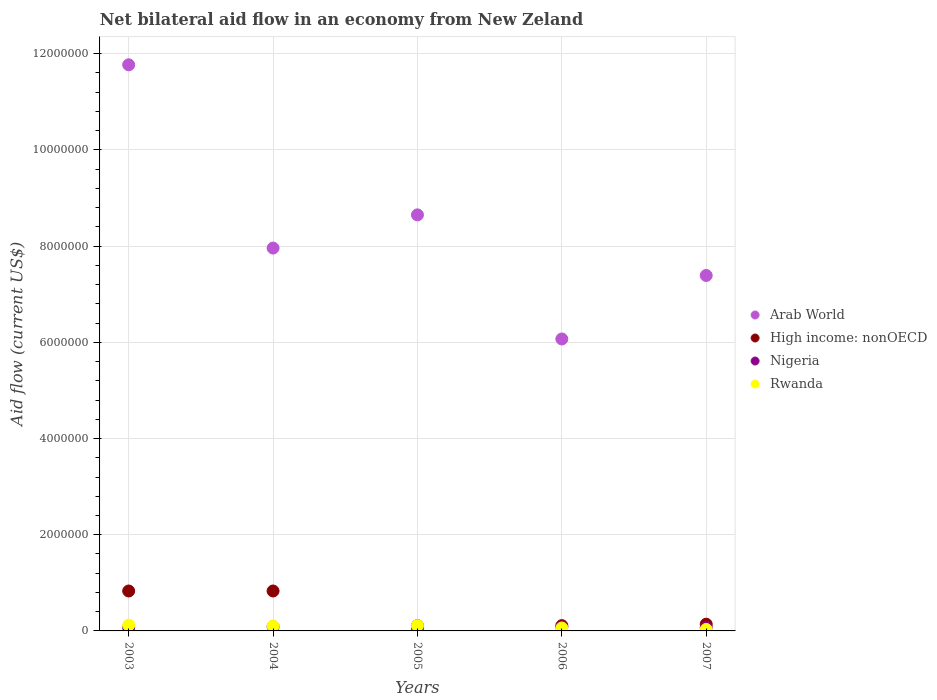What is the net bilateral aid flow in Arab World in 2006?
Ensure brevity in your answer.  6.07e+06. Across all years, what is the maximum net bilateral aid flow in Rwanda?
Offer a terse response. 1.20e+05. What is the total net bilateral aid flow in Nigeria in the graph?
Your answer should be very brief. 3.70e+05. What is the difference between the net bilateral aid flow in Nigeria in 2003 and that in 2007?
Provide a short and direct response. 0. What is the difference between the net bilateral aid flow in Arab World in 2006 and the net bilateral aid flow in High income: nonOECD in 2005?
Your answer should be compact. 5.96e+06. What is the average net bilateral aid flow in Arab World per year?
Offer a terse response. 8.37e+06. In the year 2006, what is the difference between the net bilateral aid flow in High income: nonOECD and net bilateral aid flow in Nigeria?
Make the answer very short. 3.00e+04. What is the ratio of the net bilateral aid flow in Arab World in 2006 to that in 2007?
Your response must be concise. 0.82. Is the net bilateral aid flow in High income: nonOECD in 2004 less than that in 2006?
Ensure brevity in your answer.  No. Is the difference between the net bilateral aid flow in High income: nonOECD in 2005 and 2007 greater than the difference between the net bilateral aid flow in Nigeria in 2005 and 2007?
Keep it short and to the point. No. What is the difference between the highest and the second highest net bilateral aid flow in Arab World?
Provide a succinct answer. 3.12e+06. What is the difference between the highest and the lowest net bilateral aid flow in High income: nonOECD?
Your answer should be compact. 7.20e+05. In how many years, is the net bilateral aid flow in Rwanda greater than the average net bilateral aid flow in Rwanda taken over all years?
Provide a short and direct response. 3. Is the sum of the net bilateral aid flow in Arab World in 2006 and 2007 greater than the maximum net bilateral aid flow in High income: nonOECD across all years?
Ensure brevity in your answer.  Yes. Does the net bilateral aid flow in High income: nonOECD monotonically increase over the years?
Provide a short and direct response. No. How many dotlines are there?
Offer a very short reply. 4. How many years are there in the graph?
Your answer should be very brief. 5. Are the values on the major ticks of Y-axis written in scientific E-notation?
Give a very brief answer. No. Does the graph contain any zero values?
Provide a short and direct response. No. Does the graph contain grids?
Ensure brevity in your answer.  Yes. Where does the legend appear in the graph?
Keep it short and to the point. Center right. How many legend labels are there?
Give a very brief answer. 4. What is the title of the graph?
Keep it short and to the point. Net bilateral aid flow in an economy from New Zeland. What is the label or title of the X-axis?
Your answer should be compact. Years. What is the label or title of the Y-axis?
Your response must be concise. Aid flow (current US$). What is the Aid flow (current US$) in Arab World in 2003?
Provide a short and direct response. 1.18e+07. What is the Aid flow (current US$) in High income: nonOECD in 2003?
Offer a very short reply. 8.30e+05. What is the Aid flow (current US$) of Rwanda in 2003?
Offer a very short reply. 1.20e+05. What is the Aid flow (current US$) in Arab World in 2004?
Provide a succinct answer. 7.96e+06. What is the Aid flow (current US$) of High income: nonOECD in 2004?
Your answer should be very brief. 8.30e+05. What is the Aid flow (current US$) of Rwanda in 2004?
Your answer should be very brief. 1.00e+05. What is the Aid flow (current US$) in Arab World in 2005?
Make the answer very short. 8.65e+06. What is the Aid flow (current US$) in High income: nonOECD in 2005?
Offer a very short reply. 1.10e+05. What is the Aid flow (current US$) of Arab World in 2006?
Give a very brief answer. 6.07e+06. What is the Aid flow (current US$) of Rwanda in 2006?
Keep it short and to the point. 6.00e+04. What is the Aid flow (current US$) in Arab World in 2007?
Provide a short and direct response. 7.39e+06. Across all years, what is the maximum Aid flow (current US$) in Arab World?
Offer a very short reply. 1.18e+07. Across all years, what is the maximum Aid flow (current US$) in High income: nonOECD?
Your answer should be compact. 8.30e+05. Across all years, what is the minimum Aid flow (current US$) in Arab World?
Offer a very short reply. 6.07e+06. Across all years, what is the minimum Aid flow (current US$) in High income: nonOECD?
Your answer should be very brief. 1.10e+05. Across all years, what is the minimum Aid flow (current US$) in Rwanda?
Your answer should be compact. 3.00e+04. What is the total Aid flow (current US$) of Arab World in the graph?
Your answer should be very brief. 4.18e+07. What is the total Aid flow (current US$) in High income: nonOECD in the graph?
Make the answer very short. 2.02e+06. What is the difference between the Aid flow (current US$) in Arab World in 2003 and that in 2004?
Provide a succinct answer. 3.81e+06. What is the difference between the Aid flow (current US$) of High income: nonOECD in 2003 and that in 2004?
Your response must be concise. 0. What is the difference between the Aid flow (current US$) of Arab World in 2003 and that in 2005?
Provide a short and direct response. 3.12e+06. What is the difference between the Aid flow (current US$) in High income: nonOECD in 2003 and that in 2005?
Provide a succinct answer. 7.20e+05. What is the difference between the Aid flow (current US$) in Nigeria in 2003 and that in 2005?
Provide a succinct answer. 10000. What is the difference between the Aid flow (current US$) of Arab World in 2003 and that in 2006?
Offer a very short reply. 5.70e+06. What is the difference between the Aid flow (current US$) of High income: nonOECD in 2003 and that in 2006?
Make the answer very short. 7.20e+05. What is the difference between the Aid flow (current US$) of Nigeria in 2003 and that in 2006?
Provide a short and direct response. -10000. What is the difference between the Aid flow (current US$) in Arab World in 2003 and that in 2007?
Offer a very short reply. 4.38e+06. What is the difference between the Aid flow (current US$) in High income: nonOECD in 2003 and that in 2007?
Offer a very short reply. 6.90e+05. What is the difference between the Aid flow (current US$) of Nigeria in 2003 and that in 2007?
Offer a terse response. 0. What is the difference between the Aid flow (current US$) in Rwanda in 2003 and that in 2007?
Give a very brief answer. 9.00e+04. What is the difference between the Aid flow (current US$) in Arab World in 2004 and that in 2005?
Provide a succinct answer. -6.90e+05. What is the difference between the Aid flow (current US$) of High income: nonOECD in 2004 and that in 2005?
Provide a short and direct response. 7.20e+05. What is the difference between the Aid flow (current US$) of Arab World in 2004 and that in 2006?
Give a very brief answer. 1.89e+06. What is the difference between the Aid flow (current US$) of High income: nonOECD in 2004 and that in 2006?
Offer a very short reply. 7.20e+05. What is the difference between the Aid flow (current US$) in Nigeria in 2004 and that in 2006?
Offer a terse response. 10000. What is the difference between the Aid flow (current US$) of Arab World in 2004 and that in 2007?
Provide a short and direct response. 5.70e+05. What is the difference between the Aid flow (current US$) of High income: nonOECD in 2004 and that in 2007?
Keep it short and to the point. 6.90e+05. What is the difference between the Aid flow (current US$) in Nigeria in 2004 and that in 2007?
Ensure brevity in your answer.  2.00e+04. What is the difference between the Aid flow (current US$) of Arab World in 2005 and that in 2006?
Your answer should be compact. 2.58e+06. What is the difference between the Aid flow (current US$) of High income: nonOECD in 2005 and that in 2006?
Your response must be concise. 0. What is the difference between the Aid flow (current US$) in Arab World in 2005 and that in 2007?
Your answer should be very brief. 1.26e+06. What is the difference between the Aid flow (current US$) of High income: nonOECD in 2005 and that in 2007?
Your answer should be very brief. -3.00e+04. What is the difference between the Aid flow (current US$) in Nigeria in 2005 and that in 2007?
Provide a succinct answer. -10000. What is the difference between the Aid flow (current US$) of Arab World in 2006 and that in 2007?
Keep it short and to the point. -1.32e+06. What is the difference between the Aid flow (current US$) of Nigeria in 2006 and that in 2007?
Make the answer very short. 10000. What is the difference between the Aid flow (current US$) of Arab World in 2003 and the Aid flow (current US$) of High income: nonOECD in 2004?
Offer a terse response. 1.09e+07. What is the difference between the Aid flow (current US$) in Arab World in 2003 and the Aid flow (current US$) in Nigeria in 2004?
Give a very brief answer. 1.17e+07. What is the difference between the Aid flow (current US$) of Arab World in 2003 and the Aid flow (current US$) of Rwanda in 2004?
Offer a very short reply. 1.17e+07. What is the difference between the Aid flow (current US$) in High income: nonOECD in 2003 and the Aid flow (current US$) in Nigeria in 2004?
Ensure brevity in your answer.  7.40e+05. What is the difference between the Aid flow (current US$) in High income: nonOECD in 2003 and the Aid flow (current US$) in Rwanda in 2004?
Your response must be concise. 7.30e+05. What is the difference between the Aid flow (current US$) of Nigeria in 2003 and the Aid flow (current US$) of Rwanda in 2004?
Keep it short and to the point. -3.00e+04. What is the difference between the Aid flow (current US$) in Arab World in 2003 and the Aid flow (current US$) in High income: nonOECD in 2005?
Make the answer very short. 1.17e+07. What is the difference between the Aid flow (current US$) in Arab World in 2003 and the Aid flow (current US$) in Nigeria in 2005?
Ensure brevity in your answer.  1.17e+07. What is the difference between the Aid flow (current US$) in Arab World in 2003 and the Aid flow (current US$) in Rwanda in 2005?
Ensure brevity in your answer.  1.17e+07. What is the difference between the Aid flow (current US$) of High income: nonOECD in 2003 and the Aid flow (current US$) of Nigeria in 2005?
Keep it short and to the point. 7.70e+05. What is the difference between the Aid flow (current US$) of High income: nonOECD in 2003 and the Aid flow (current US$) of Rwanda in 2005?
Offer a terse response. 7.20e+05. What is the difference between the Aid flow (current US$) of Nigeria in 2003 and the Aid flow (current US$) of Rwanda in 2005?
Offer a very short reply. -4.00e+04. What is the difference between the Aid flow (current US$) in Arab World in 2003 and the Aid flow (current US$) in High income: nonOECD in 2006?
Provide a short and direct response. 1.17e+07. What is the difference between the Aid flow (current US$) of Arab World in 2003 and the Aid flow (current US$) of Nigeria in 2006?
Give a very brief answer. 1.17e+07. What is the difference between the Aid flow (current US$) of Arab World in 2003 and the Aid flow (current US$) of Rwanda in 2006?
Your answer should be compact. 1.17e+07. What is the difference between the Aid flow (current US$) in High income: nonOECD in 2003 and the Aid flow (current US$) in Nigeria in 2006?
Offer a very short reply. 7.50e+05. What is the difference between the Aid flow (current US$) of High income: nonOECD in 2003 and the Aid flow (current US$) of Rwanda in 2006?
Give a very brief answer. 7.70e+05. What is the difference between the Aid flow (current US$) of Nigeria in 2003 and the Aid flow (current US$) of Rwanda in 2006?
Offer a terse response. 10000. What is the difference between the Aid flow (current US$) in Arab World in 2003 and the Aid flow (current US$) in High income: nonOECD in 2007?
Your response must be concise. 1.16e+07. What is the difference between the Aid flow (current US$) in Arab World in 2003 and the Aid flow (current US$) in Nigeria in 2007?
Ensure brevity in your answer.  1.17e+07. What is the difference between the Aid flow (current US$) in Arab World in 2003 and the Aid flow (current US$) in Rwanda in 2007?
Offer a terse response. 1.17e+07. What is the difference between the Aid flow (current US$) of High income: nonOECD in 2003 and the Aid flow (current US$) of Nigeria in 2007?
Your response must be concise. 7.60e+05. What is the difference between the Aid flow (current US$) in High income: nonOECD in 2003 and the Aid flow (current US$) in Rwanda in 2007?
Make the answer very short. 8.00e+05. What is the difference between the Aid flow (current US$) in Nigeria in 2003 and the Aid flow (current US$) in Rwanda in 2007?
Offer a very short reply. 4.00e+04. What is the difference between the Aid flow (current US$) in Arab World in 2004 and the Aid flow (current US$) in High income: nonOECD in 2005?
Provide a short and direct response. 7.85e+06. What is the difference between the Aid flow (current US$) of Arab World in 2004 and the Aid flow (current US$) of Nigeria in 2005?
Make the answer very short. 7.90e+06. What is the difference between the Aid flow (current US$) in Arab World in 2004 and the Aid flow (current US$) in Rwanda in 2005?
Ensure brevity in your answer.  7.85e+06. What is the difference between the Aid flow (current US$) in High income: nonOECD in 2004 and the Aid flow (current US$) in Nigeria in 2005?
Give a very brief answer. 7.70e+05. What is the difference between the Aid flow (current US$) in High income: nonOECD in 2004 and the Aid flow (current US$) in Rwanda in 2005?
Offer a very short reply. 7.20e+05. What is the difference between the Aid flow (current US$) of Nigeria in 2004 and the Aid flow (current US$) of Rwanda in 2005?
Your answer should be compact. -2.00e+04. What is the difference between the Aid flow (current US$) of Arab World in 2004 and the Aid flow (current US$) of High income: nonOECD in 2006?
Give a very brief answer. 7.85e+06. What is the difference between the Aid flow (current US$) of Arab World in 2004 and the Aid flow (current US$) of Nigeria in 2006?
Provide a succinct answer. 7.88e+06. What is the difference between the Aid flow (current US$) of Arab World in 2004 and the Aid flow (current US$) of Rwanda in 2006?
Provide a short and direct response. 7.90e+06. What is the difference between the Aid flow (current US$) of High income: nonOECD in 2004 and the Aid flow (current US$) of Nigeria in 2006?
Offer a very short reply. 7.50e+05. What is the difference between the Aid flow (current US$) in High income: nonOECD in 2004 and the Aid flow (current US$) in Rwanda in 2006?
Ensure brevity in your answer.  7.70e+05. What is the difference between the Aid flow (current US$) in Nigeria in 2004 and the Aid flow (current US$) in Rwanda in 2006?
Provide a succinct answer. 3.00e+04. What is the difference between the Aid flow (current US$) of Arab World in 2004 and the Aid flow (current US$) of High income: nonOECD in 2007?
Provide a short and direct response. 7.82e+06. What is the difference between the Aid flow (current US$) in Arab World in 2004 and the Aid flow (current US$) in Nigeria in 2007?
Your answer should be compact. 7.89e+06. What is the difference between the Aid flow (current US$) in Arab World in 2004 and the Aid flow (current US$) in Rwanda in 2007?
Your answer should be very brief. 7.93e+06. What is the difference between the Aid flow (current US$) in High income: nonOECD in 2004 and the Aid flow (current US$) in Nigeria in 2007?
Make the answer very short. 7.60e+05. What is the difference between the Aid flow (current US$) in High income: nonOECD in 2004 and the Aid flow (current US$) in Rwanda in 2007?
Keep it short and to the point. 8.00e+05. What is the difference between the Aid flow (current US$) of Arab World in 2005 and the Aid flow (current US$) of High income: nonOECD in 2006?
Provide a short and direct response. 8.54e+06. What is the difference between the Aid flow (current US$) in Arab World in 2005 and the Aid flow (current US$) in Nigeria in 2006?
Your answer should be compact. 8.57e+06. What is the difference between the Aid flow (current US$) of Arab World in 2005 and the Aid flow (current US$) of Rwanda in 2006?
Provide a short and direct response. 8.59e+06. What is the difference between the Aid flow (current US$) in High income: nonOECD in 2005 and the Aid flow (current US$) in Nigeria in 2006?
Keep it short and to the point. 3.00e+04. What is the difference between the Aid flow (current US$) in Nigeria in 2005 and the Aid flow (current US$) in Rwanda in 2006?
Give a very brief answer. 0. What is the difference between the Aid flow (current US$) in Arab World in 2005 and the Aid flow (current US$) in High income: nonOECD in 2007?
Make the answer very short. 8.51e+06. What is the difference between the Aid flow (current US$) of Arab World in 2005 and the Aid flow (current US$) of Nigeria in 2007?
Provide a succinct answer. 8.58e+06. What is the difference between the Aid flow (current US$) in Arab World in 2005 and the Aid flow (current US$) in Rwanda in 2007?
Your answer should be very brief. 8.62e+06. What is the difference between the Aid flow (current US$) in Nigeria in 2005 and the Aid flow (current US$) in Rwanda in 2007?
Offer a terse response. 3.00e+04. What is the difference between the Aid flow (current US$) in Arab World in 2006 and the Aid flow (current US$) in High income: nonOECD in 2007?
Provide a short and direct response. 5.93e+06. What is the difference between the Aid flow (current US$) in Arab World in 2006 and the Aid flow (current US$) in Rwanda in 2007?
Ensure brevity in your answer.  6.04e+06. What is the difference between the Aid flow (current US$) of Nigeria in 2006 and the Aid flow (current US$) of Rwanda in 2007?
Offer a terse response. 5.00e+04. What is the average Aid flow (current US$) in Arab World per year?
Provide a short and direct response. 8.37e+06. What is the average Aid flow (current US$) of High income: nonOECD per year?
Offer a terse response. 4.04e+05. What is the average Aid flow (current US$) in Nigeria per year?
Offer a terse response. 7.40e+04. What is the average Aid flow (current US$) in Rwanda per year?
Your response must be concise. 8.40e+04. In the year 2003, what is the difference between the Aid flow (current US$) of Arab World and Aid flow (current US$) of High income: nonOECD?
Offer a very short reply. 1.09e+07. In the year 2003, what is the difference between the Aid flow (current US$) of Arab World and Aid flow (current US$) of Nigeria?
Your answer should be very brief. 1.17e+07. In the year 2003, what is the difference between the Aid flow (current US$) of Arab World and Aid flow (current US$) of Rwanda?
Provide a short and direct response. 1.16e+07. In the year 2003, what is the difference between the Aid flow (current US$) of High income: nonOECD and Aid flow (current US$) of Nigeria?
Provide a succinct answer. 7.60e+05. In the year 2003, what is the difference between the Aid flow (current US$) in High income: nonOECD and Aid flow (current US$) in Rwanda?
Offer a terse response. 7.10e+05. In the year 2003, what is the difference between the Aid flow (current US$) of Nigeria and Aid flow (current US$) of Rwanda?
Your response must be concise. -5.00e+04. In the year 2004, what is the difference between the Aid flow (current US$) of Arab World and Aid flow (current US$) of High income: nonOECD?
Provide a succinct answer. 7.13e+06. In the year 2004, what is the difference between the Aid flow (current US$) in Arab World and Aid flow (current US$) in Nigeria?
Provide a succinct answer. 7.87e+06. In the year 2004, what is the difference between the Aid flow (current US$) of Arab World and Aid flow (current US$) of Rwanda?
Make the answer very short. 7.86e+06. In the year 2004, what is the difference between the Aid flow (current US$) in High income: nonOECD and Aid flow (current US$) in Nigeria?
Provide a succinct answer. 7.40e+05. In the year 2004, what is the difference between the Aid flow (current US$) in High income: nonOECD and Aid flow (current US$) in Rwanda?
Your response must be concise. 7.30e+05. In the year 2005, what is the difference between the Aid flow (current US$) in Arab World and Aid flow (current US$) in High income: nonOECD?
Ensure brevity in your answer.  8.54e+06. In the year 2005, what is the difference between the Aid flow (current US$) in Arab World and Aid flow (current US$) in Nigeria?
Offer a terse response. 8.59e+06. In the year 2005, what is the difference between the Aid flow (current US$) of Arab World and Aid flow (current US$) of Rwanda?
Offer a terse response. 8.54e+06. In the year 2005, what is the difference between the Aid flow (current US$) in High income: nonOECD and Aid flow (current US$) in Nigeria?
Your answer should be very brief. 5.00e+04. In the year 2006, what is the difference between the Aid flow (current US$) in Arab World and Aid flow (current US$) in High income: nonOECD?
Offer a very short reply. 5.96e+06. In the year 2006, what is the difference between the Aid flow (current US$) in Arab World and Aid flow (current US$) in Nigeria?
Ensure brevity in your answer.  5.99e+06. In the year 2006, what is the difference between the Aid flow (current US$) of Arab World and Aid flow (current US$) of Rwanda?
Your answer should be very brief. 6.01e+06. In the year 2006, what is the difference between the Aid flow (current US$) in High income: nonOECD and Aid flow (current US$) in Nigeria?
Keep it short and to the point. 3.00e+04. In the year 2006, what is the difference between the Aid flow (current US$) in Nigeria and Aid flow (current US$) in Rwanda?
Your response must be concise. 2.00e+04. In the year 2007, what is the difference between the Aid flow (current US$) in Arab World and Aid flow (current US$) in High income: nonOECD?
Your answer should be compact. 7.25e+06. In the year 2007, what is the difference between the Aid flow (current US$) in Arab World and Aid flow (current US$) in Nigeria?
Your answer should be very brief. 7.32e+06. In the year 2007, what is the difference between the Aid flow (current US$) of Arab World and Aid flow (current US$) of Rwanda?
Offer a terse response. 7.36e+06. In the year 2007, what is the difference between the Aid flow (current US$) of High income: nonOECD and Aid flow (current US$) of Rwanda?
Keep it short and to the point. 1.10e+05. What is the ratio of the Aid flow (current US$) of Arab World in 2003 to that in 2004?
Keep it short and to the point. 1.48. What is the ratio of the Aid flow (current US$) of Rwanda in 2003 to that in 2004?
Provide a succinct answer. 1.2. What is the ratio of the Aid flow (current US$) in Arab World in 2003 to that in 2005?
Keep it short and to the point. 1.36. What is the ratio of the Aid flow (current US$) of High income: nonOECD in 2003 to that in 2005?
Offer a terse response. 7.55. What is the ratio of the Aid flow (current US$) of Arab World in 2003 to that in 2006?
Your answer should be very brief. 1.94. What is the ratio of the Aid flow (current US$) of High income: nonOECD in 2003 to that in 2006?
Offer a terse response. 7.55. What is the ratio of the Aid flow (current US$) in Nigeria in 2003 to that in 2006?
Provide a succinct answer. 0.88. What is the ratio of the Aid flow (current US$) of Arab World in 2003 to that in 2007?
Your answer should be very brief. 1.59. What is the ratio of the Aid flow (current US$) in High income: nonOECD in 2003 to that in 2007?
Make the answer very short. 5.93. What is the ratio of the Aid flow (current US$) in Arab World in 2004 to that in 2005?
Give a very brief answer. 0.92. What is the ratio of the Aid flow (current US$) of High income: nonOECD in 2004 to that in 2005?
Make the answer very short. 7.55. What is the ratio of the Aid flow (current US$) in Rwanda in 2004 to that in 2005?
Your answer should be compact. 0.91. What is the ratio of the Aid flow (current US$) of Arab World in 2004 to that in 2006?
Your answer should be very brief. 1.31. What is the ratio of the Aid flow (current US$) in High income: nonOECD in 2004 to that in 2006?
Your answer should be compact. 7.55. What is the ratio of the Aid flow (current US$) in Rwanda in 2004 to that in 2006?
Give a very brief answer. 1.67. What is the ratio of the Aid flow (current US$) of Arab World in 2004 to that in 2007?
Your answer should be very brief. 1.08. What is the ratio of the Aid flow (current US$) of High income: nonOECD in 2004 to that in 2007?
Make the answer very short. 5.93. What is the ratio of the Aid flow (current US$) in Nigeria in 2004 to that in 2007?
Your answer should be very brief. 1.29. What is the ratio of the Aid flow (current US$) of Arab World in 2005 to that in 2006?
Offer a very short reply. 1.43. What is the ratio of the Aid flow (current US$) of High income: nonOECD in 2005 to that in 2006?
Keep it short and to the point. 1. What is the ratio of the Aid flow (current US$) in Rwanda in 2005 to that in 2006?
Keep it short and to the point. 1.83. What is the ratio of the Aid flow (current US$) of Arab World in 2005 to that in 2007?
Ensure brevity in your answer.  1.17. What is the ratio of the Aid flow (current US$) in High income: nonOECD in 2005 to that in 2007?
Your answer should be very brief. 0.79. What is the ratio of the Aid flow (current US$) in Nigeria in 2005 to that in 2007?
Your answer should be compact. 0.86. What is the ratio of the Aid flow (current US$) in Rwanda in 2005 to that in 2007?
Provide a succinct answer. 3.67. What is the ratio of the Aid flow (current US$) of Arab World in 2006 to that in 2007?
Your answer should be very brief. 0.82. What is the ratio of the Aid flow (current US$) in High income: nonOECD in 2006 to that in 2007?
Provide a short and direct response. 0.79. What is the ratio of the Aid flow (current US$) in Rwanda in 2006 to that in 2007?
Your answer should be compact. 2. What is the difference between the highest and the second highest Aid flow (current US$) in Arab World?
Your response must be concise. 3.12e+06. What is the difference between the highest and the second highest Aid flow (current US$) of High income: nonOECD?
Provide a succinct answer. 0. What is the difference between the highest and the lowest Aid flow (current US$) in Arab World?
Your answer should be compact. 5.70e+06. What is the difference between the highest and the lowest Aid flow (current US$) of High income: nonOECD?
Give a very brief answer. 7.20e+05. 